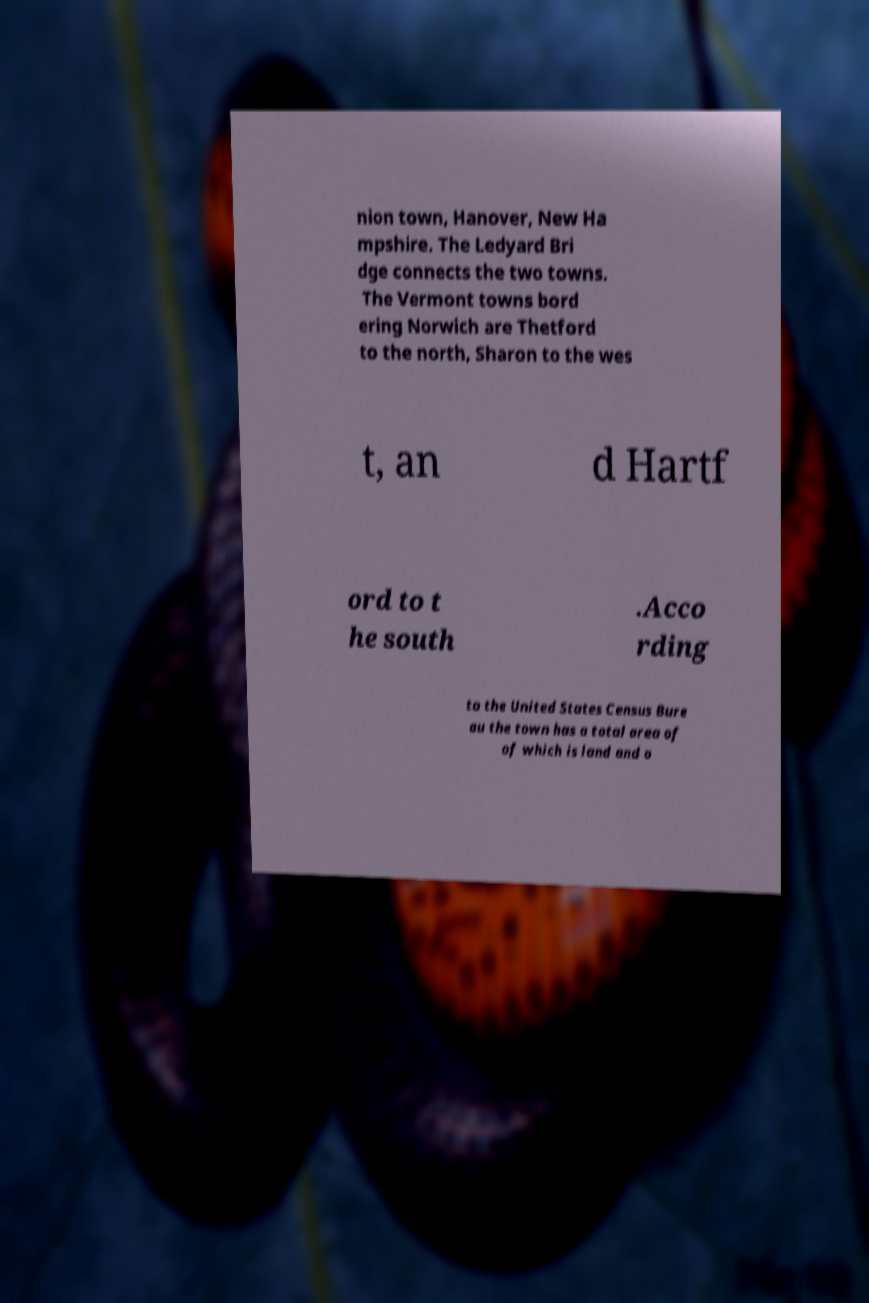Please identify and transcribe the text found in this image. nion town, Hanover, New Ha mpshire. The Ledyard Bri dge connects the two towns. The Vermont towns bord ering Norwich are Thetford to the north, Sharon to the wes t, an d Hartf ord to t he south .Acco rding to the United States Census Bure au the town has a total area of of which is land and o 